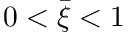Convert formula to latex. <formula><loc_0><loc_0><loc_500><loc_500>0 < \bar { \xi } < 1</formula> 